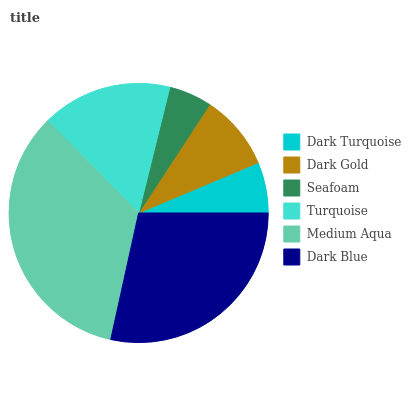Is Seafoam the minimum?
Answer yes or no. Yes. Is Medium Aqua the maximum?
Answer yes or no. Yes. Is Dark Gold the minimum?
Answer yes or no. No. Is Dark Gold the maximum?
Answer yes or no. No. Is Dark Gold greater than Dark Turquoise?
Answer yes or no. Yes. Is Dark Turquoise less than Dark Gold?
Answer yes or no. Yes. Is Dark Turquoise greater than Dark Gold?
Answer yes or no. No. Is Dark Gold less than Dark Turquoise?
Answer yes or no. No. Is Turquoise the high median?
Answer yes or no. Yes. Is Dark Gold the low median?
Answer yes or no. Yes. Is Medium Aqua the high median?
Answer yes or no. No. Is Turquoise the low median?
Answer yes or no. No. 